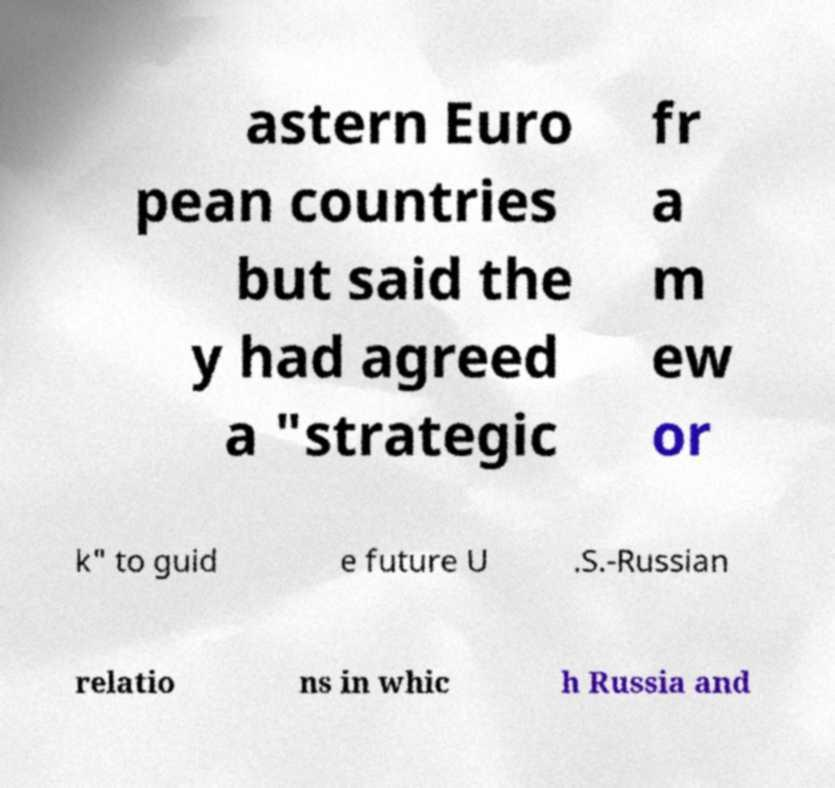Could you extract and type out the text from this image? astern Euro pean countries but said the y had agreed a "strategic fr a m ew or k" to guid e future U .S.-Russian relatio ns in whic h Russia and 